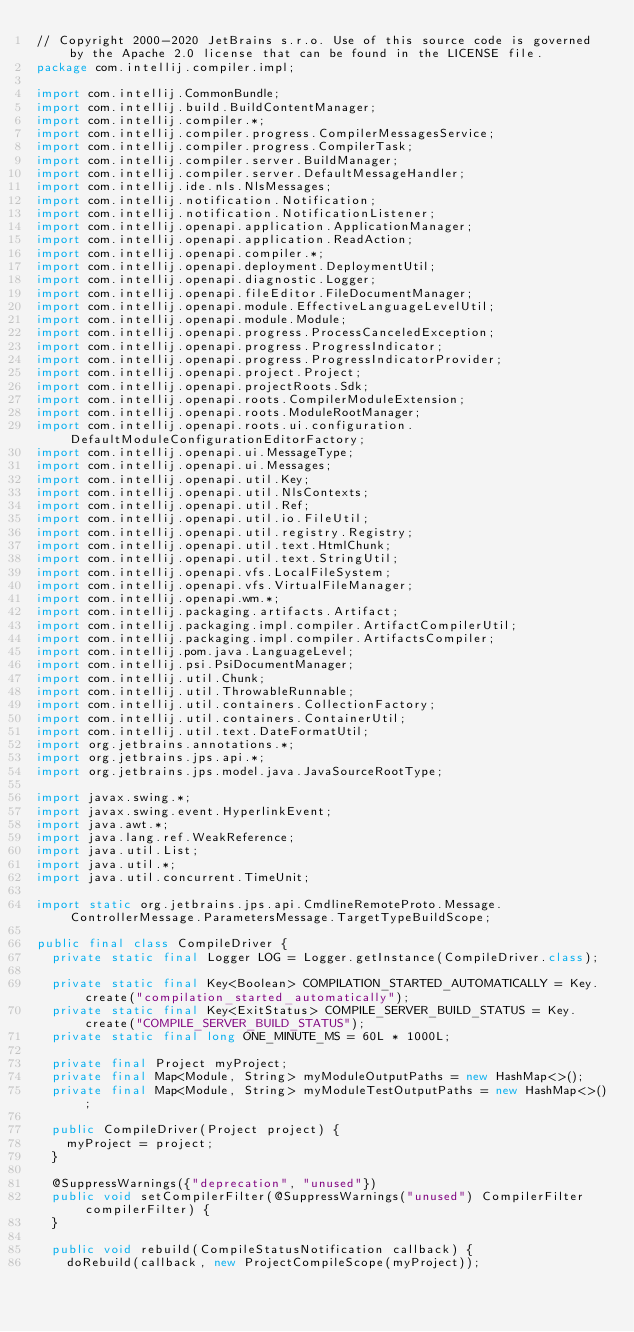<code> <loc_0><loc_0><loc_500><loc_500><_Java_>// Copyright 2000-2020 JetBrains s.r.o. Use of this source code is governed by the Apache 2.0 license that can be found in the LICENSE file.
package com.intellij.compiler.impl;

import com.intellij.CommonBundle;
import com.intellij.build.BuildContentManager;
import com.intellij.compiler.*;
import com.intellij.compiler.progress.CompilerMessagesService;
import com.intellij.compiler.progress.CompilerTask;
import com.intellij.compiler.server.BuildManager;
import com.intellij.compiler.server.DefaultMessageHandler;
import com.intellij.ide.nls.NlsMessages;
import com.intellij.notification.Notification;
import com.intellij.notification.NotificationListener;
import com.intellij.openapi.application.ApplicationManager;
import com.intellij.openapi.application.ReadAction;
import com.intellij.openapi.compiler.*;
import com.intellij.openapi.deployment.DeploymentUtil;
import com.intellij.openapi.diagnostic.Logger;
import com.intellij.openapi.fileEditor.FileDocumentManager;
import com.intellij.openapi.module.EffectiveLanguageLevelUtil;
import com.intellij.openapi.module.Module;
import com.intellij.openapi.progress.ProcessCanceledException;
import com.intellij.openapi.progress.ProgressIndicator;
import com.intellij.openapi.progress.ProgressIndicatorProvider;
import com.intellij.openapi.project.Project;
import com.intellij.openapi.projectRoots.Sdk;
import com.intellij.openapi.roots.CompilerModuleExtension;
import com.intellij.openapi.roots.ModuleRootManager;
import com.intellij.openapi.roots.ui.configuration.DefaultModuleConfigurationEditorFactory;
import com.intellij.openapi.ui.MessageType;
import com.intellij.openapi.ui.Messages;
import com.intellij.openapi.util.Key;
import com.intellij.openapi.util.NlsContexts;
import com.intellij.openapi.util.Ref;
import com.intellij.openapi.util.io.FileUtil;
import com.intellij.openapi.util.registry.Registry;
import com.intellij.openapi.util.text.HtmlChunk;
import com.intellij.openapi.util.text.StringUtil;
import com.intellij.openapi.vfs.LocalFileSystem;
import com.intellij.openapi.vfs.VirtualFileManager;
import com.intellij.openapi.wm.*;
import com.intellij.packaging.artifacts.Artifact;
import com.intellij.packaging.impl.compiler.ArtifactCompilerUtil;
import com.intellij.packaging.impl.compiler.ArtifactsCompiler;
import com.intellij.pom.java.LanguageLevel;
import com.intellij.psi.PsiDocumentManager;
import com.intellij.util.Chunk;
import com.intellij.util.ThrowableRunnable;
import com.intellij.util.containers.CollectionFactory;
import com.intellij.util.containers.ContainerUtil;
import com.intellij.util.text.DateFormatUtil;
import org.jetbrains.annotations.*;
import org.jetbrains.jps.api.*;
import org.jetbrains.jps.model.java.JavaSourceRootType;

import javax.swing.*;
import javax.swing.event.HyperlinkEvent;
import java.awt.*;
import java.lang.ref.WeakReference;
import java.util.List;
import java.util.*;
import java.util.concurrent.TimeUnit;

import static org.jetbrains.jps.api.CmdlineRemoteProto.Message.ControllerMessage.ParametersMessage.TargetTypeBuildScope;

public final class CompileDriver {
  private static final Logger LOG = Logger.getInstance(CompileDriver.class);

  private static final Key<Boolean> COMPILATION_STARTED_AUTOMATICALLY = Key.create("compilation_started_automatically");
  private static final Key<ExitStatus> COMPILE_SERVER_BUILD_STATUS = Key.create("COMPILE_SERVER_BUILD_STATUS");
  private static final long ONE_MINUTE_MS = 60L * 1000L;

  private final Project myProject;
  private final Map<Module, String> myModuleOutputPaths = new HashMap<>();
  private final Map<Module, String> myModuleTestOutputPaths = new HashMap<>();

  public CompileDriver(Project project) {
    myProject = project;
  }

  @SuppressWarnings({"deprecation", "unused"})
  public void setCompilerFilter(@SuppressWarnings("unused") CompilerFilter compilerFilter) {
  }

  public void rebuild(CompileStatusNotification callback) {
    doRebuild(callback, new ProjectCompileScope(myProject));</code> 